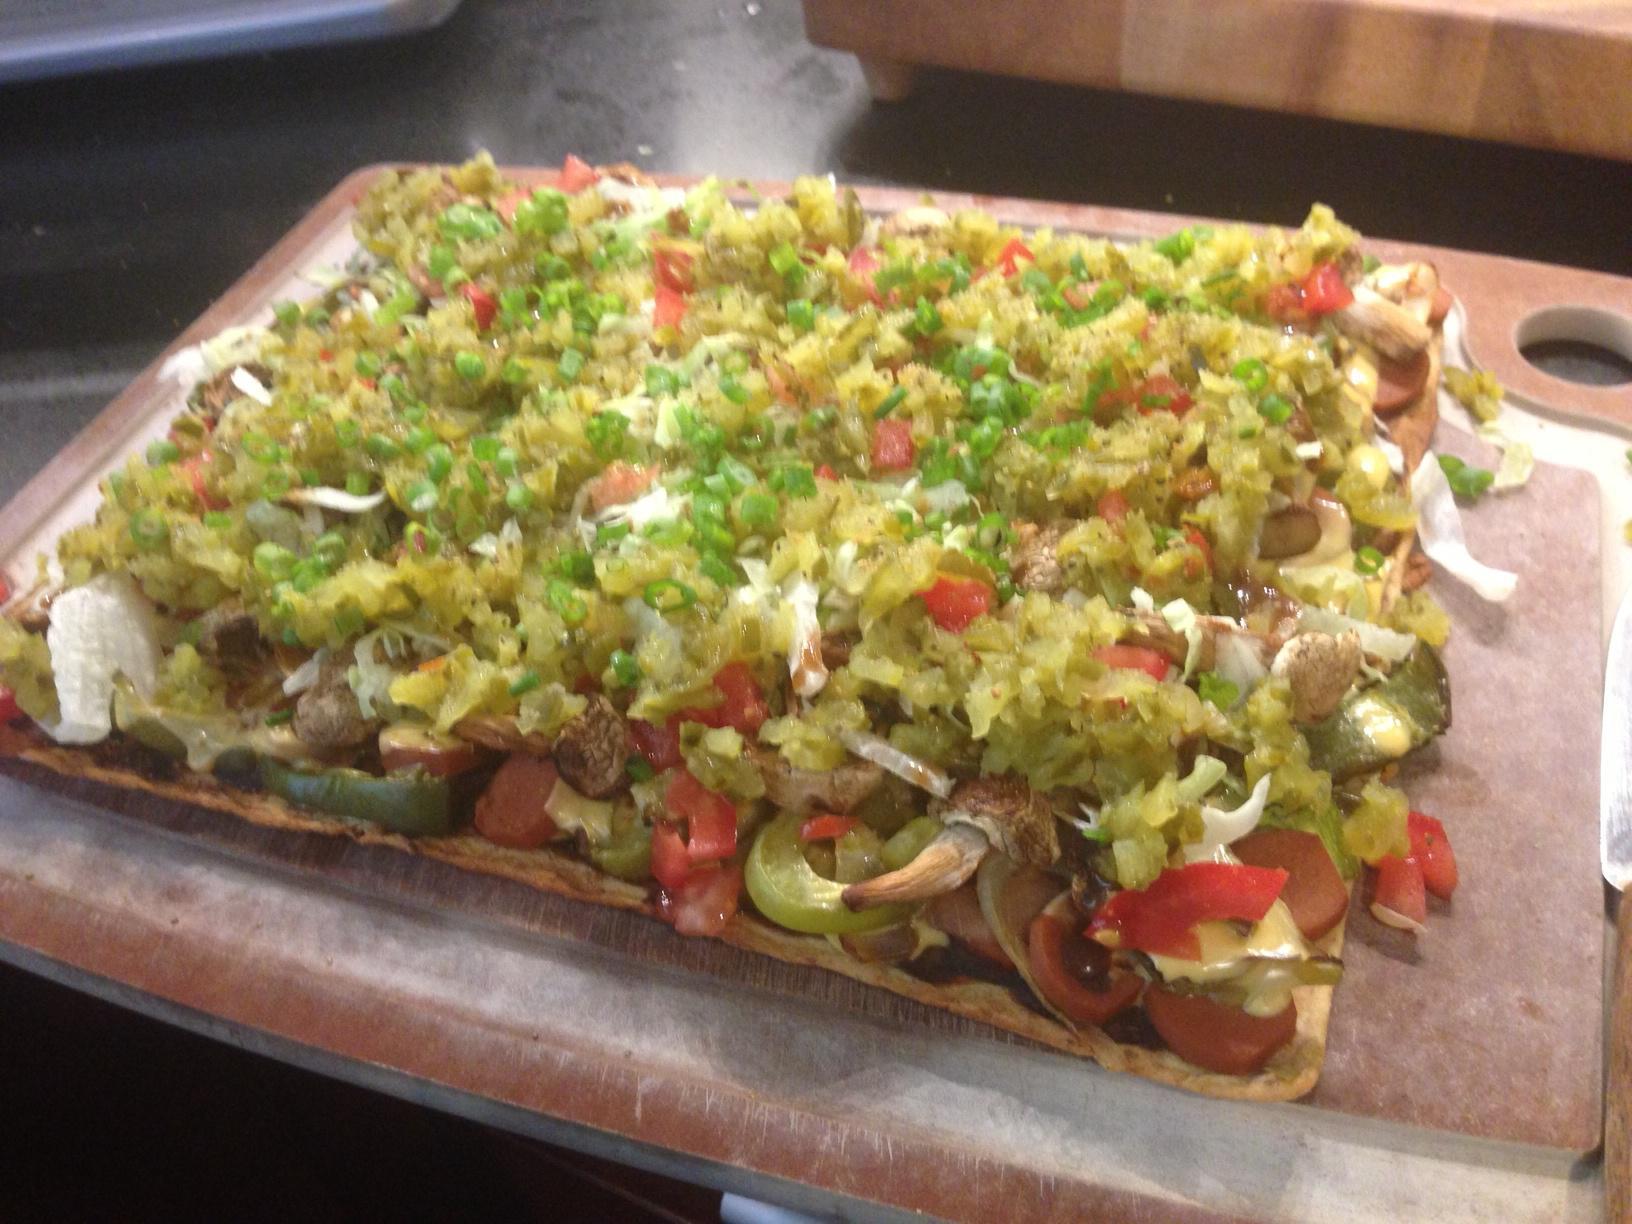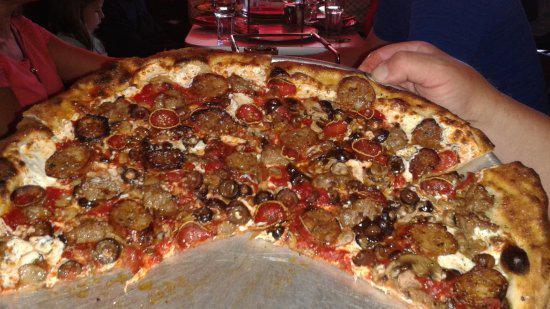The first image is the image on the left, the second image is the image on the right. For the images shown, is this caption "There is one round pizza in each image." true? Answer yes or no. No. 